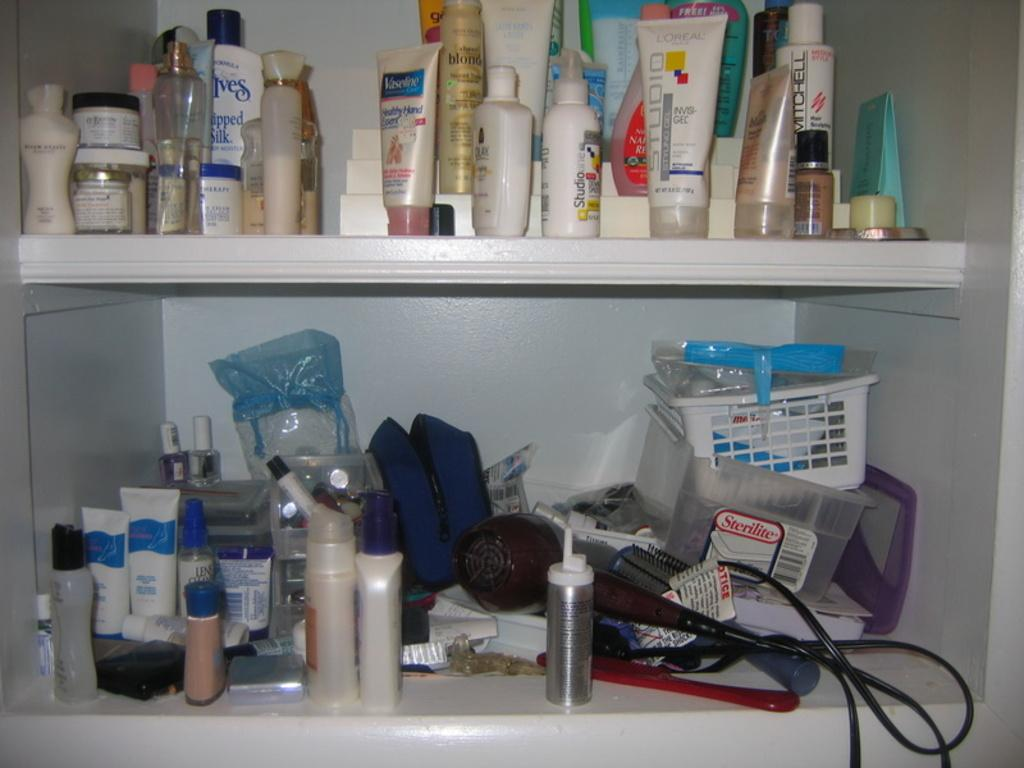<image>
Render a clear and concise summary of the photo. the two shelves has the beauty  and personal care products with white transparent  box which has sticker named as Sterilite 